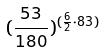<formula> <loc_0><loc_0><loc_500><loc_500>( \frac { 5 3 } { 1 8 0 } ) ^ { ( \frac { 6 } { 2 } \cdot 8 3 ) }</formula> 